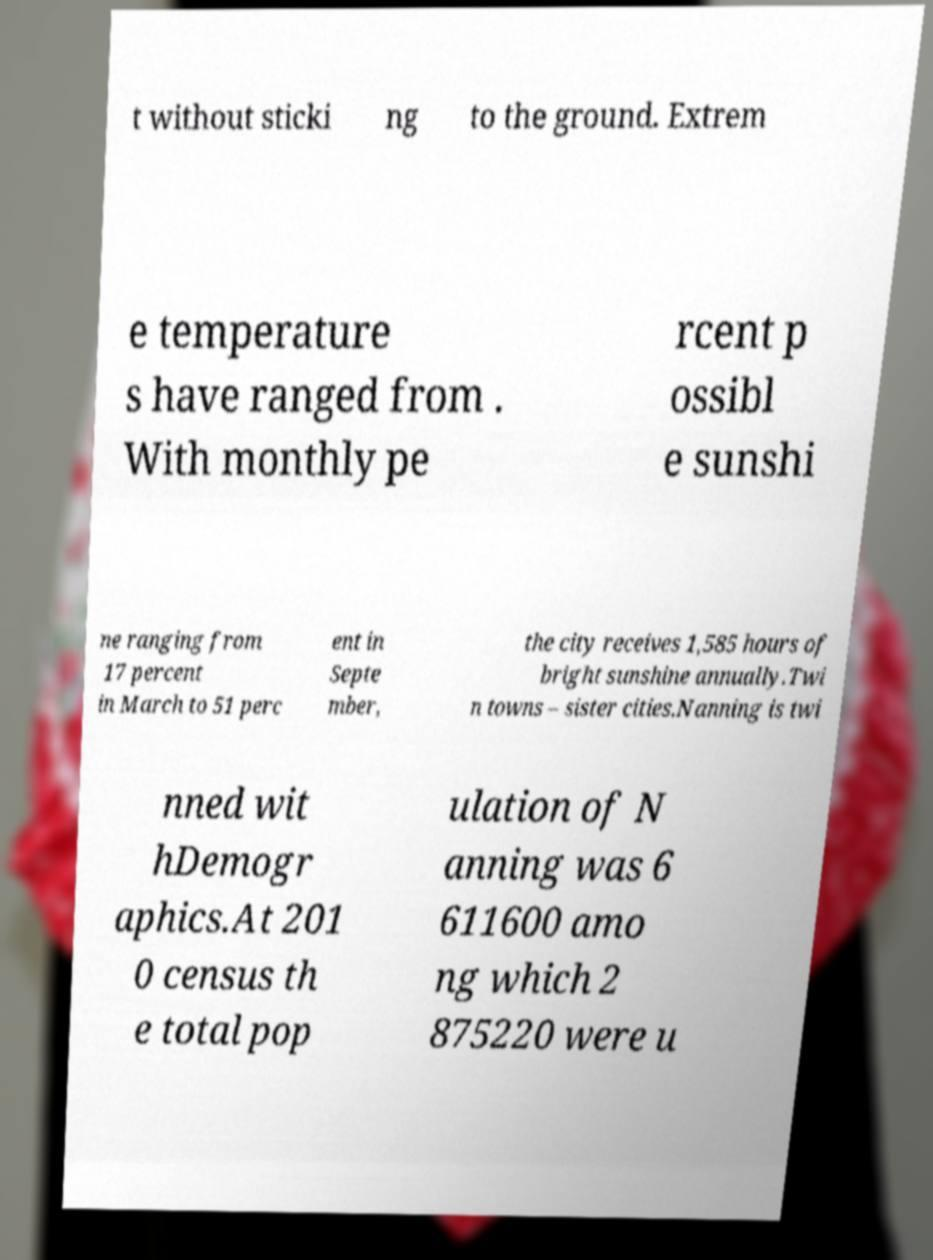Can you read and provide the text displayed in the image?This photo seems to have some interesting text. Can you extract and type it out for me? t without sticki ng to the ground. Extrem e temperature s have ranged from . With monthly pe rcent p ossibl e sunshi ne ranging from 17 percent in March to 51 perc ent in Septe mber, the city receives 1,585 hours of bright sunshine annually.Twi n towns – sister cities.Nanning is twi nned wit hDemogr aphics.At 201 0 census th e total pop ulation of N anning was 6 611600 amo ng which 2 875220 were u 